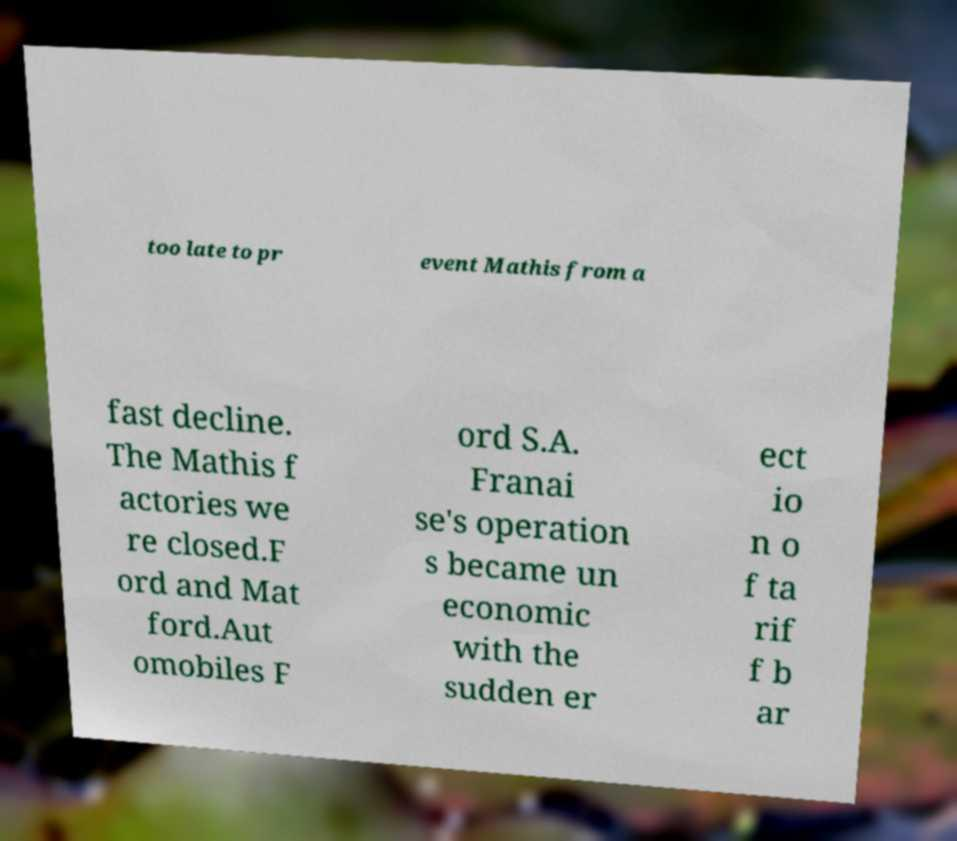Could you extract and type out the text from this image? too late to pr event Mathis from a fast decline. The Mathis f actories we re closed.F ord and Mat ford.Aut omobiles F ord S.A. Franai se's operation s became un economic with the sudden er ect io n o f ta rif f b ar 